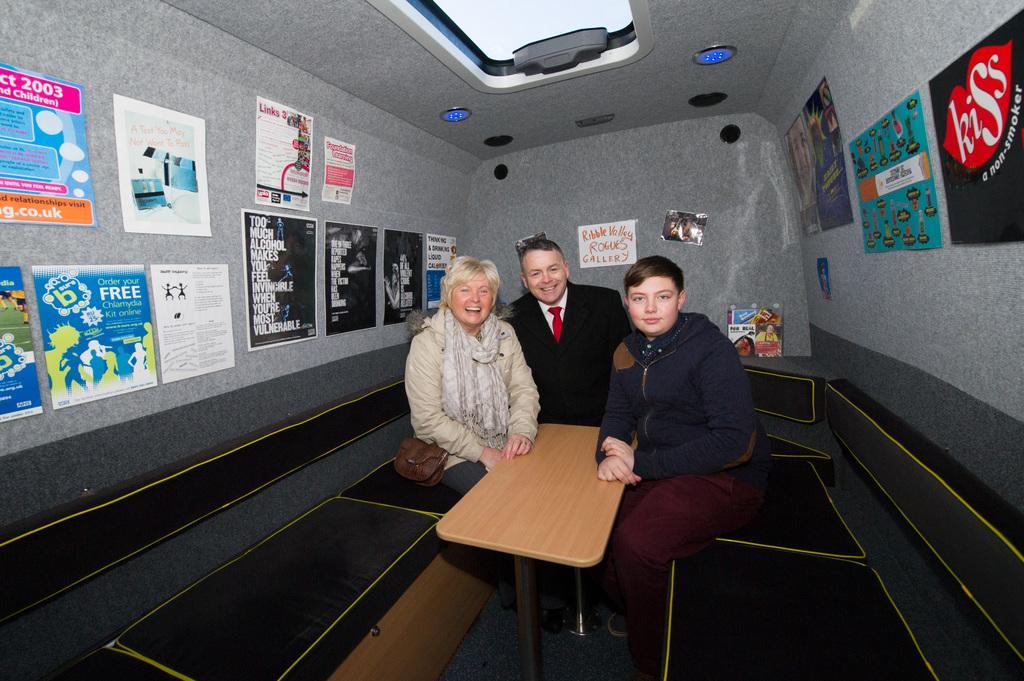How would you summarize this image in a sentence or two? This image consists of paper pasted on the left side and right side. There are lights on the top. There are three people sitting. One is man other one is child and another one is woman. There is a table in between them. All of them are smiling. 